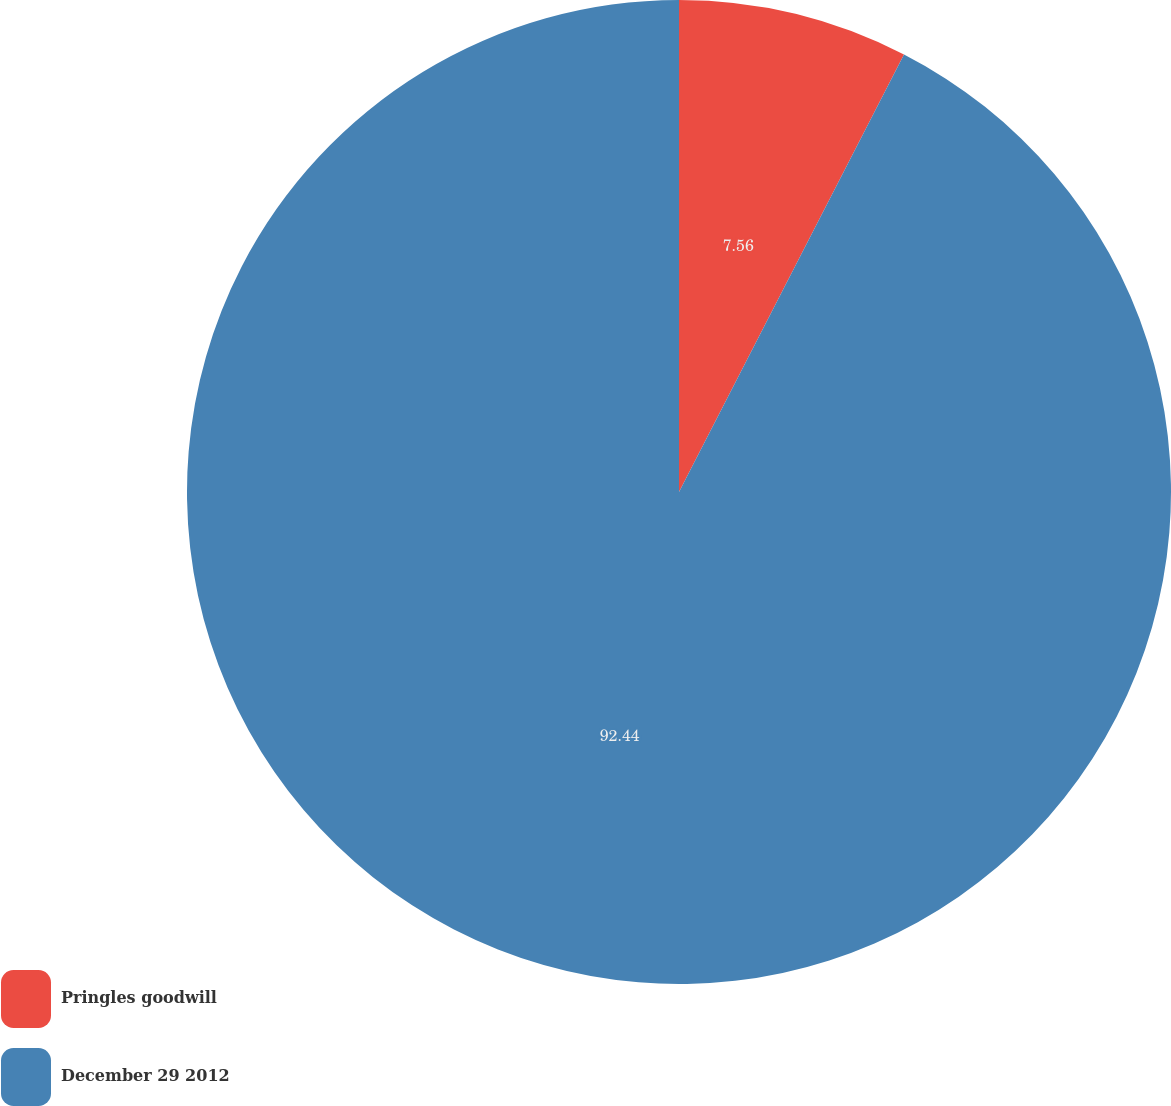<chart> <loc_0><loc_0><loc_500><loc_500><pie_chart><fcel>Pringles goodwill<fcel>December 29 2012<nl><fcel>7.56%<fcel>92.44%<nl></chart> 